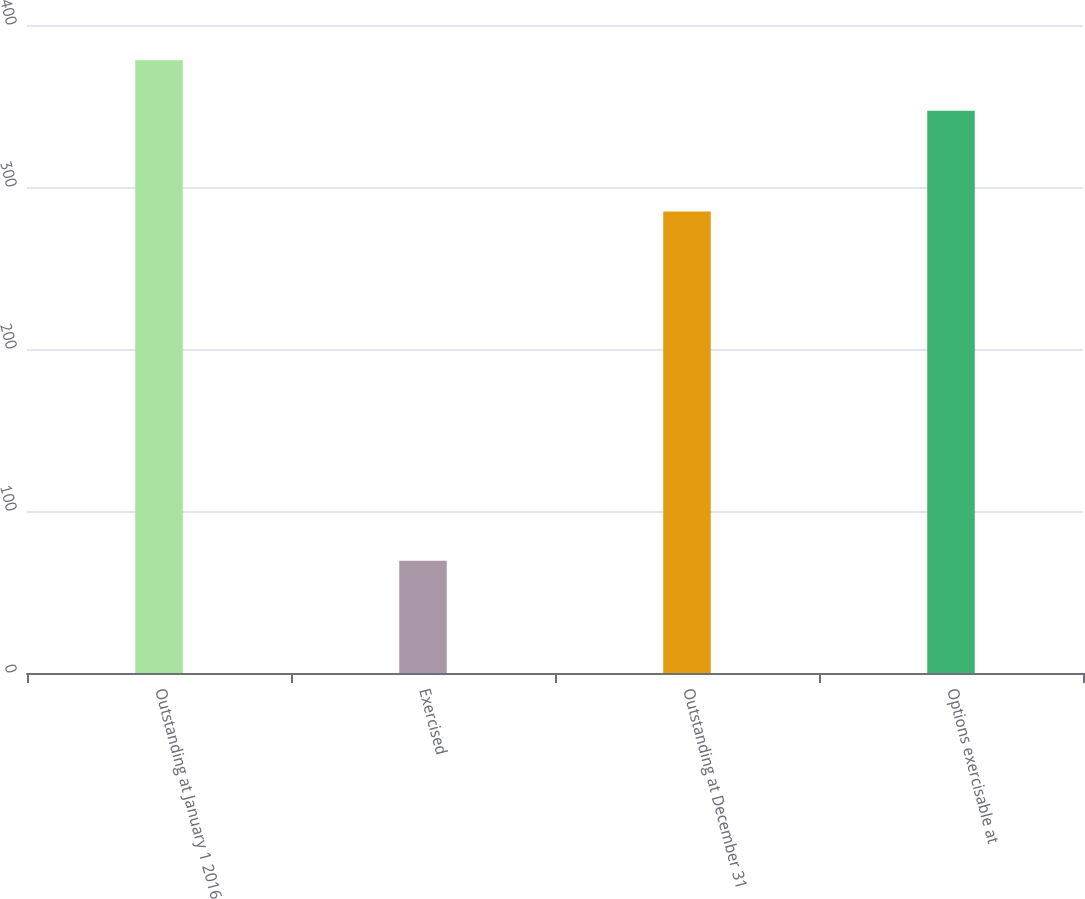Convert chart. <chart><loc_0><loc_0><loc_500><loc_500><bar_chart><fcel>Outstanding at January 1 2016<fcel>Exercised<fcel>Outstanding at December 31<fcel>Options exercisable at<nl><fcel>378.17<fcel>69.3<fcel>284.9<fcel>347.08<nl></chart> 